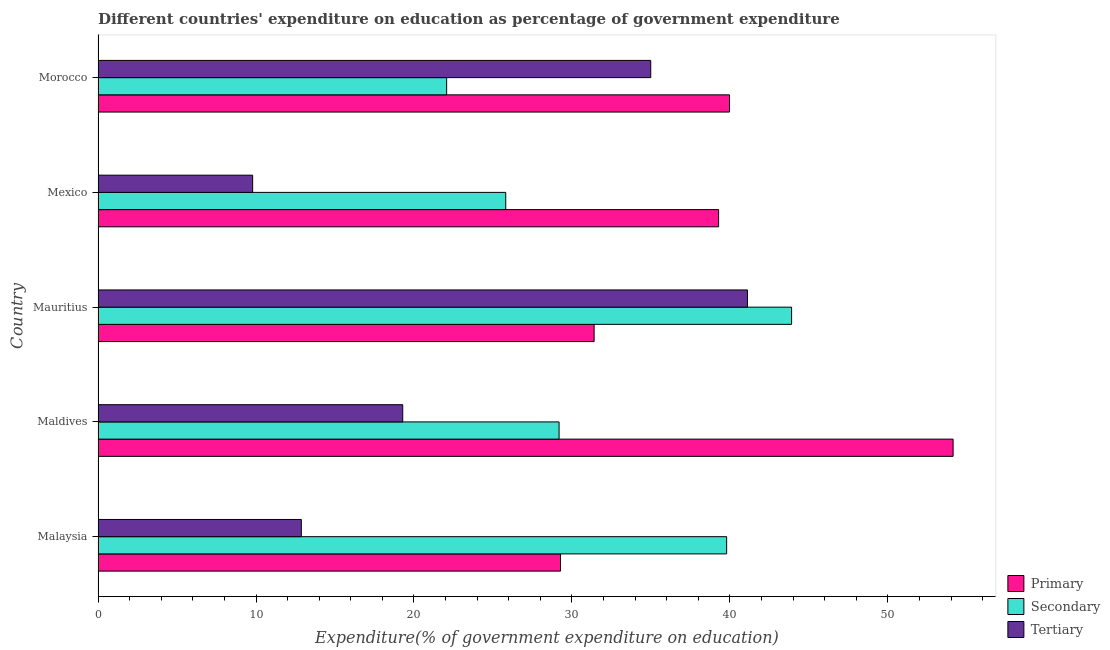Are the number of bars per tick equal to the number of legend labels?
Your response must be concise. Yes. What is the label of the 5th group of bars from the top?
Your answer should be very brief. Malaysia. In how many cases, is the number of bars for a given country not equal to the number of legend labels?
Ensure brevity in your answer.  0. What is the expenditure on tertiary education in Mauritius?
Make the answer very short. 41.11. Across all countries, what is the maximum expenditure on primary education?
Make the answer very short. 54.13. Across all countries, what is the minimum expenditure on tertiary education?
Your response must be concise. 9.79. In which country was the expenditure on tertiary education maximum?
Give a very brief answer. Mauritius. In which country was the expenditure on primary education minimum?
Offer a terse response. Malaysia. What is the total expenditure on primary education in the graph?
Offer a very short reply. 194.07. What is the difference between the expenditure on primary education in Malaysia and that in Mexico?
Your answer should be very brief. -10.01. What is the difference between the expenditure on tertiary education in Malaysia and the expenditure on secondary education in Mauritius?
Your response must be concise. -31.04. What is the average expenditure on primary education per country?
Provide a succinct answer. 38.81. What is the difference between the expenditure on primary education and expenditure on secondary education in Malaysia?
Your answer should be very brief. -10.52. In how many countries, is the expenditure on tertiary education greater than 18 %?
Offer a very short reply. 3. What is the ratio of the expenditure on tertiary education in Mauritius to that in Morocco?
Your response must be concise. 1.18. What is the difference between the highest and the second highest expenditure on primary education?
Provide a succinct answer. 14.15. What is the difference between the highest and the lowest expenditure on tertiary education?
Provide a succinct answer. 31.32. What does the 2nd bar from the top in Morocco represents?
Provide a short and direct response. Secondary. What does the 1st bar from the bottom in Morocco represents?
Give a very brief answer. Primary. How many bars are there?
Your response must be concise. 15. How many legend labels are there?
Provide a succinct answer. 3. How are the legend labels stacked?
Keep it short and to the point. Vertical. What is the title of the graph?
Provide a succinct answer. Different countries' expenditure on education as percentage of government expenditure. Does "Taxes on international trade" appear as one of the legend labels in the graph?
Your answer should be compact. No. What is the label or title of the X-axis?
Provide a short and direct response. Expenditure(% of government expenditure on education). What is the Expenditure(% of government expenditure on education) in Primary in Malaysia?
Offer a terse response. 29.28. What is the Expenditure(% of government expenditure on education) of Secondary in Malaysia?
Offer a terse response. 39.79. What is the Expenditure(% of government expenditure on education) of Tertiary in Malaysia?
Provide a succinct answer. 12.87. What is the Expenditure(% of government expenditure on education) of Primary in Maldives?
Keep it short and to the point. 54.13. What is the Expenditure(% of government expenditure on education) of Secondary in Maldives?
Make the answer very short. 29.18. What is the Expenditure(% of government expenditure on education) in Tertiary in Maldives?
Your answer should be very brief. 19.29. What is the Expenditure(% of government expenditure on education) of Primary in Mauritius?
Your response must be concise. 31.4. What is the Expenditure(% of government expenditure on education) of Secondary in Mauritius?
Offer a terse response. 43.9. What is the Expenditure(% of government expenditure on education) of Tertiary in Mauritius?
Your answer should be very brief. 41.11. What is the Expenditure(% of government expenditure on education) in Primary in Mexico?
Ensure brevity in your answer.  39.28. What is the Expenditure(% of government expenditure on education) in Secondary in Mexico?
Your answer should be compact. 25.81. What is the Expenditure(% of government expenditure on education) in Tertiary in Mexico?
Offer a very short reply. 9.79. What is the Expenditure(% of government expenditure on education) of Primary in Morocco?
Offer a very short reply. 39.97. What is the Expenditure(% of government expenditure on education) in Secondary in Morocco?
Offer a terse response. 22.07. What is the Expenditure(% of government expenditure on education) of Tertiary in Morocco?
Provide a succinct answer. 34.99. Across all countries, what is the maximum Expenditure(% of government expenditure on education) in Primary?
Offer a terse response. 54.13. Across all countries, what is the maximum Expenditure(% of government expenditure on education) of Secondary?
Your answer should be very brief. 43.9. Across all countries, what is the maximum Expenditure(% of government expenditure on education) in Tertiary?
Provide a succinct answer. 41.11. Across all countries, what is the minimum Expenditure(% of government expenditure on education) in Primary?
Provide a succinct answer. 29.28. Across all countries, what is the minimum Expenditure(% of government expenditure on education) in Secondary?
Your response must be concise. 22.07. Across all countries, what is the minimum Expenditure(% of government expenditure on education) in Tertiary?
Offer a terse response. 9.79. What is the total Expenditure(% of government expenditure on education) in Primary in the graph?
Offer a very short reply. 194.07. What is the total Expenditure(% of government expenditure on education) in Secondary in the graph?
Give a very brief answer. 160.76. What is the total Expenditure(% of government expenditure on education) of Tertiary in the graph?
Provide a succinct answer. 118.04. What is the difference between the Expenditure(% of government expenditure on education) of Primary in Malaysia and that in Maldives?
Offer a terse response. -24.85. What is the difference between the Expenditure(% of government expenditure on education) of Secondary in Malaysia and that in Maldives?
Your response must be concise. 10.61. What is the difference between the Expenditure(% of government expenditure on education) of Tertiary in Malaysia and that in Maldives?
Your response must be concise. -6.42. What is the difference between the Expenditure(% of government expenditure on education) in Primary in Malaysia and that in Mauritius?
Your response must be concise. -2.13. What is the difference between the Expenditure(% of government expenditure on education) of Secondary in Malaysia and that in Mauritius?
Your response must be concise. -4.11. What is the difference between the Expenditure(% of government expenditure on education) of Tertiary in Malaysia and that in Mauritius?
Give a very brief answer. -28.24. What is the difference between the Expenditure(% of government expenditure on education) of Primary in Malaysia and that in Mexico?
Keep it short and to the point. -10.01. What is the difference between the Expenditure(% of government expenditure on education) of Secondary in Malaysia and that in Mexico?
Give a very brief answer. 13.98. What is the difference between the Expenditure(% of government expenditure on education) of Tertiary in Malaysia and that in Mexico?
Provide a succinct answer. 3.08. What is the difference between the Expenditure(% of government expenditure on education) in Primary in Malaysia and that in Morocco?
Keep it short and to the point. -10.7. What is the difference between the Expenditure(% of government expenditure on education) in Secondary in Malaysia and that in Morocco?
Make the answer very short. 17.72. What is the difference between the Expenditure(% of government expenditure on education) of Tertiary in Malaysia and that in Morocco?
Your answer should be very brief. -22.12. What is the difference between the Expenditure(% of government expenditure on education) in Primary in Maldives and that in Mauritius?
Your answer should be compact. 22.73. What is the difference between the Expenditure(% of government expenditure on education) in Secondary in Maldives and that in Mauritius?
Offer a terse response. -14.72. What is the difference between the Expenditure(% of government expenditure on education) in Tertiary in Maldives and that in Mauritius?
Provide a short and direct response. -21.82. What is the difference between the Expenditure(% of government expenditure on education) of Primary in Maldives and that in Mexico?
Your response must be concise. 14.85. What is the difference between the Expenditure(% of government expenditure on education) of Secondary in Maldives and that in Mexico?
Offer a very short reply. 3.38. What is the difference between the Expenditure(% of government expenditure on education) of Tertiary in Maldives and that in Mexico?
Give a very brief answer. 9.5. What is the difference between the Expenditure(% of government expenditure on education) in Primary in Maldives and that in Morocco?
Make the answer very short. 14.15. What is the difference between the Expenditure(% of government expenditure on education) in Secondary in Maldives and that in Morocco?
Keep it short and to the point. 7.12. What is the difference between the Expenditure(% of government expenditure on education) in Tertiary in Maldives and that in Morocco?
Make the answer very short. -15.7. What is the difference between the Expenditure(% of government expenditure on education) in Primary in Mauritius and that in Mexico?
Offer a very short reply. -7.88. What is the difference between the Expenditure(% of government expenditure on education) in Secondary in Mauritius and that in Mexico?
Your response must be concise. 18.1. What is the difference between the Expenditure(% of government expenditure on education) of Tertiary in Mauritius and that in Mexico?
Provide a succinct answer. 31.32. What is the difference between the Expenditure(% of government expenditure on education) of Primary in Mauritius and that in Morocco?
Your response must be concise. -8.57. What is the difference between the Expenditure(% of government expenditure on education) of Secondary in Mauritius and that in Morocco?
Your response must be concise. 21.84. What is the difference between the Expenditure(% of government expenditure on education) of Tertiary in Mauritius and that in Morocco?
Make the answer very short. 6.12. What is the difference between the Expenditure(% of government expenditure on education) in Primary in Mexico and that in Morocco?
Your response must be concise. -0.69. What is the difference between the Expenditure(% of government expenditure on education) of Secondary in Mexico and that in Morocco?
Give a very brief answer. 3.74. What is the difference between the Expenditure(% of government expenditure on education) of Tertiary in Mexico and that in Morocco?
Provide a succinct answer. -25.2. What is the difference between the Expenditure(% of government expenditure on education) in Primary in Malaysia and the Expenditure(% of government expenditure on education) in Secondary in Maldives?
Ensure brevity in your answer.  0.09. What is the difference between the Expenditure(% of government expenditure on education) in Primary in Malaysia and the Expenditure(% of government expenditure on education) in Tertiary in Maldives?
Your answer should be very brief. 9.99. What is the difference between the Expenditure(% of government expenditure on education) of Secondary in Malaysia and the Expenditure(% of government expenditure on education) of Tertiary in Maldives?
Make the answer very short. 20.5. What is the difference between the Expenditure(% of government expenditure on education) in Primary in Malaysia and the Expenditure(% of government expenditure on education) in Secondary in Mauritius?
Provide a succinct answer. -14.63. What is the difference between the Expenditure(% of government expenditure on education) of Primary in Malaysia and the Expenditure(% of government expenditure on education) of Tertiary in Mauritius?
Offer a terse response. -11.83. What is the difference between the Expenditure(% of government expenditure on education) in Secondary in Malaysia and the Expenditure(% of government expenditure on education) in Tertiary in Mauritius?
Make the answer very short. -1.32. What is the difference between the Expenditure(% of government expenditure on education) of Primary in Malaysia and the Expenditure(% of government expenditure on education) of Secondary in Mexico?
Provide a succinct answer. 3.47. What is the difference between the Expenditure(% of government expenditure on education) of Primary in Malaysia and the Expenditure(% of government expenditure on education) of Tertiary in Mexico?
Offer a terse response. 19.49. What is the difference between the Expenditure(% of government expenditure on education) in Secondary in Malaysia and the Expenditure(% of government expenditure on education) in Tertiary in Mexico?
Your response must be concise. 30. What is the difference between the Expenditure(% of government expenditure on education) in Primary in Malaysia and the Expenditure(% of government expenditure on education) in Secondary in Morocco?
Your answer should be compact. 7.21. What is the difference between the Expenditure(% of government expenditure on education) in Primary in Malaysia and the Expenditure(% of government expenditure on education) in Tertiary in Morocco?
Your response must be concise. -5.71. What is the difference between the Expenditure(% of government expenditure on education) in Secondary in Malaysia and the Expenditure(% of government expenditure on education) in Tertiary in Morocco?
Your answer should be very brief. 4.8. What is the difference between the Expenditure(% of government expenditure on education) in Primary in Maldives and the Expenditure(% of government expenditure on education) in Secondary in Mauritius?
Offer a terse response. 10.22. What is the difference between the Expenditure(% of government expenditure on education) of Primary in Maldives and the Expenditure(% of government expenditure on education) of Tertiary in Mauritius?
Offer a very short reply. 13.02. What is the difference between the Expenditure(% of government expenditure on education) of Secondary in Maldives and the Expenditure(% of government expenditure on education) of Tertiary in Mauritius?
Ensure brevity in your answer.  -11.92. What is the difference between the Expenditure(% of government expenditure on education) in Primary in Maldives and the Expenditure(% of government expenditure on education) in Secondary in Mexico?
Offer a very short reply. 28.32. What is the difference between the Expenditure(% of government expenditure on education) in Primary in Maldives and the Expenditure(% of government expenditure on education) in Tertiary in Mexico?
Provide a succinct answer. 44.34. What is the difference between the Expenditure(% of government expenditure on education) of Secondary in Maldives and the Expenditure(% of government expenditure on education) of Tertiary in Mexico?
Offer a terse response. 19.4. What is the difference between the Expenditure(% of government expenditure on education) of Primary in Maldives and the Expenditure(% of government expenditure on education) of Secondary in Morocco?
Provide a short and direct response. 32.06. What is the difference between the Expenditure(% of government expenditure on education) of Primary in Maldives and the Expenditure(% of government expenditure on education) of Tertiary in Morocco?
Your response must be concise. 19.14. What is the difference between the Expenditure(% of government expenditure on education) in Secondary in Maldives and the Expenditure(% of government expenditure on education) in Tertiary in Morocco?
Offer a terse response. -5.8. What is the difference between the Expenditure(% of government expenditure on education) in Primary in Mauritius and the Expenditure(% of government expenditure on education) in Secondary in Mexico?
Offer a very short reply. 5.59. What is the difference between the Expenditure(% of government expenditure on education) in Primary in Mauritius and the Expenditure(% of government expenditure on education) in Tertiary in Mexico?
Offer a very short reply. 21.62. What is the difference between the Expenditure(% of government expenditure on education) of Secondary in Mauritius and the Expenditure(% of government expenditure on education) of Tertiary in Mexico?
Keep it short and to the point. 34.12. What is the difference between the Expenditure(% of government expenditure on education) of Primary in Mauritius and the Expenditure(% of government expenditure on education) of Secondary in Morocco?
Your answer should be compact. 9.34. What is the difference between the Expenditure(% of government expenditure on education) in Primary in Mauritius and the Expenditure(% of government expenditure on education) in Tertiary in Morocco?
Ensure brevity in your answer.  -3.58. What is the difference between the Expenditure(% of government expenditure on education) of Secondary in Mauritius and the Expenditure(% of government expenditure on education) of Tertiary in Morocco?
Offer a very short reply. 8.92. What is the difference between the Expenditure(% of government expenditure on education) in Primary in Mexico and the Expenditure(% of government expenditure on education) in Secondary in Morocco?
Offer a very short reply. 17.22. What is the difference between the Expenditure(% of government expenditure on education) in Primary in Mexico and the Expenditure(% of government expenditure on education) in Tertiary in Morocco?
Your response must be concise. 4.3. What is the difference between the Expenditure(% of government expenditure on education) in Secondary in Mexico and the Expenditure(% of government expenditure on education) in Tertiary in Morocco?
Keep it short and to the point. -9.18. What is the average Expenditure(% of government expenditure on education) in Primary per country?
Your answer should be very brief. 38.81. What is the average Expenditure(% of government expenditure on education) in Secondary per country?
Offer a very short reply. 32.15. What is the average Expenditure(% of government expenditure on education) in Tertiary per country?
Offer a terse response. 23.61. What is the difference between the Expenditure(% of government expenditure on education) in Primary and Expenditure(% of government expenditure on education) in Secondary in Malaysia?
Provide a short and direct response. -10.51. What is the difference between the Expenditure(% of government expenditure on education) of Primary and Expenditure(% of government expenditure on education) of Tertiary in Malaysia?
Make the answer very short. 16.41. What is the difference between the Expenditure(% of government expenditure on education) of Secondary and Expenditure(% of government expenditure on education) of Tertiary in Malaysia?
Your answer should be very brief. 26.92. What is the difference between the Expenditure(% of government expenditure on education) of Primary and Expenditure(% of government expenditure on education) of Secondary in Maldives?
Ensure brevity in your answer.  24.94. What is the difference between the Expenditure(% of government expenditure on education) in Primary and Expenditure(% of government expenditure on education) in Tertiary in Maldives?
Give a very brief answer. 34.84. What is the difference between the Expenditure(% of government expenditure on education) of Secondary and Expenditure(% of government expenditure on education) of Tertiary in Maldives?
Give a very brief answer. 9.9. What is the difference between the Expenditure(% of government expenditure on education) of Primary and Expenditure(% of government expenditure on education) of Secondary in Mauritius?
Offer a terse response. -12.5. What is the difference between the Expenditure(% of government expenditure on education) of Primary and Expenditure(% of government expenditure on education) of Tertiary in Mauritius?
Offer a very short reply. -9.71. What is the difference between the Expenditure(% of government expenditure on education) in Secondary and Expenditure(% of government expenditure on education) in Tertiary in Mauritius?
Your answer should be very brief. 2.79. What is the difference between the Expenditure(% of government expenditure on education) of Primary and Expenditure(% of government expenditure on education) of Secondary in Mexico?
Offer a terse response. 13.47. What is the difference between the Expenditure(% of government expenditure on education) of Primary and Expenditure(% of government expenditure on education) of Tertiary in Mexico?
Your answer should be very brief. 29.5. What is the difference between the Expenditure(% of government expenditure on education) of Secondary and Expenditure(% of government expenditure on education) of Tertiary in Mexico?
Keep it short and to the point. 16.02. What is the difference between the Expenditure(% of government expenditure on education) of Primary and Expenditure(% of government expenditure on education) of Secondary in Morocco?
Your answer should be very brief. 17.91. What is the difference between the Expenditure(% of government expenditure on education) of Primary and Expenditure(% of government expenditure on education) of Tertiary in Morocco?
Provide a succinct answer. 4.99. What is the difference between the Expenditure(% of government expenditure on education) of Secondary and Expenditure(% of government expenditure on education) of Tertiary in Morocco?
Make the answer very short. -12.92. What is the ratio of the Expenditure(% of government expenditure on education) of Primary in Malaysia to that in Maldives?
Your response must be concise. 0.54. What is the ratio of the Expenditure(% of government expenditure on education) of Secondary in Malaysia to that in Maldives?
Give a very brief answer. 1.36. What is the ratio of the Expenditure(% of government expenditure on education) of Tertiary in Malaysia to that in Maldives?
Make the answer very short. 0.67. What is the ratio of the Expenditure(% of government expenditure on education) in Primary in Malaysia to that in Mauritius?
Provide a short and direct response. 0.93. What is the ratio of the Expenditure(% of government expenditure on education) of Secondary in Malaysia to that in Mauritius?
Your answer should be compact. 0.91. What is the ratio of the Expenditure(% of government expenditure on education) in Tertiary in Malaysia to that in Mauritius?
Offer a terse response. 0.31. What is the ratio of the Expenditure(% of government expenditure on education) in Primary in Malaysia to that in Mexico?
Provide a short and direct response. 0.75. What is the ratio of the Expenditure(% of government expenditure on education) of Secondary in Malaysia to that in Mexico?
Your answer should be very brief. 1.54. What is the ratio of the Expenditure(% of government expenditure on education) in Tertiary in Malaysia to that in Mexico?
Your answer should be compact. 1.31. What is the ratio of the Expenditure(% of government expenditure on education) of Primary in Malaysia to that in Morocco?
Offer a terse response. 0.73. What is the ratio of the Expenditure(% of government expenditure on education) in Secondary in Malaysia to that in Morocco?
Keep it short and to the point. 1.8. What is the ratio of the Expenditure(% of government expenditure on education) in Tertiary in Malaysia to that in Morocco?
Provide a short and direct response. 0.37. What is the ratio of the Expenditure(% of government expenditure on education) of Primary in Maldives to that in Mauritius?
Ensure brevity in your answer.  1.72. What is the ratio of the Expenditure(% of government expenditure on education) of Secondary in Maldives to that in Mauritius?
Provide a succinct answer. 0.66. What is the ratio of the Expenditure(% of government expenditure on education) in Tertiary in Maldives to that in Mauritius?
Your response must be concise. 0.47. What is the ratio of the Expenditure(% of government expenditure on education) in Primary in Maldives to that in Mexico?
Offer a terse response. 1.38. What is the ratio of the Expenditure(% of government expenditure on education) in Secondary in Maldives to that in Mexico?
Provide a short and direct response. 1.13. What is the ratio of the Expenditure(% of government expenditure on education) in Tertiary in Maldives to that in Mexico?
Your response must be concise. 1.97. What is the ratio of the Expenditure(% of government expenditure on education) of Primary in Maldives to that in Morocco?
Give a very brief answer. 1.35. What is the ratio of the Expenditure(% of government expenditure on education) in Secondary in Maldives to that in Morocco?
Keep it short and to the point. 1.32. What is the ratio of the Expenditure(% of government expenditure on education) in Tertiary in Maldives to that in Morocco?
Provide a succinct answer. 0.55. What is the ratio of the Expenditure(% of government expenditure on education) in Primary in Mauritius to that in Mexico?
Give a very brief answer. 0.8. What is the ratio of the Expenditure(% of government expenditure on education) of Secondary in Mauritius to that in Mexico?
Provide a succinct answer. 1.7. What is the ratio of the Expenditure(% of government expenditure on education) of Tertiary in Mauritius to that in Mexico?
Keep it short and to the point. 4.2. What is the ratio of the Expenditure(% of government expenditure on education) in Primary in Mauritius to that in Morocco?
Your answer should be very brief. 0.79. What is the ratio of the Expenditure(% of government expenditure on education) in Secondary in Mauritius to that in Morocco?
Your answer should be very brief. 1.99. What is the ratio of the Expenditure(% of government expenditure on education) in Tertiary in Mauritius to that in Morocco?
Your answer should be compact. 1.18. What is the ratio of the Expenditure(% of government expenditure on education) of Primary in Mexico to that in Morocco?
Ensure brevity in your answer.  0.98. What is the ratio of the Expenditure(% of government expenditure on education) of Secondary in Mexico to that in Morocco?
Provide a short and direct response. 1.17. What is the ratio of the Expenditure(% of government expenditure on education) of Tertiary in Mexico to that in Morocco?
Offer a terse response. 0.28. What is the difference between the highest and the second highest Expenditure(% of government expenditure on education) of Primary?
Ensure brevity in your answer.  14.15. What is the difference between the highest and the second highest Expenditure(% of government expenditure on education) in Secondary?
Your answer should be very brief. 4.11. What is the difference between the highest and the second highest Expenditure(% of government expenditure on education) in Tertiary?
Give a very brief answer. 6.12. What is the difference between the highest and the lowest Expenditure(% of government expenditure on education) in Primary?
Provide a succinct answer. 24.85. What is the difference between the highest and the lowest Expenditure(% of government expenditure on education) of Secondary?
Your answer should be very brief. 21.84. What is the difference between the highest and the lowest Expenditure(% of government expenditure on education) in Tertiary?
Your response must be concise. 31.32. 